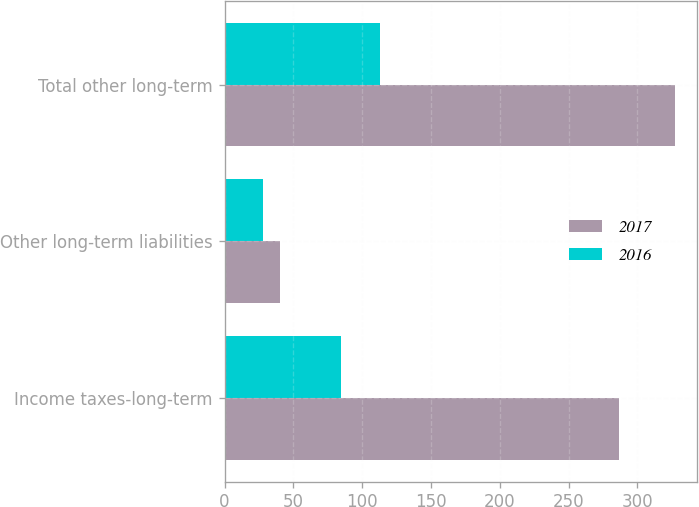Convert chart to OTSL. <chart><loc_0><loc_0><loc_500><loc_500><stacked_bar_chart><ecel><fcel>Income taxes-long-term<fcel>Other long-term liabilities<fcel>Total other long-term<nl><fcel>2017<fcel>286.8<fcel>40.3<fcel>327.1<nl><fcel>2016<fcel>84.9<fcel>27.7<fcel>112.6<nl></chart> 